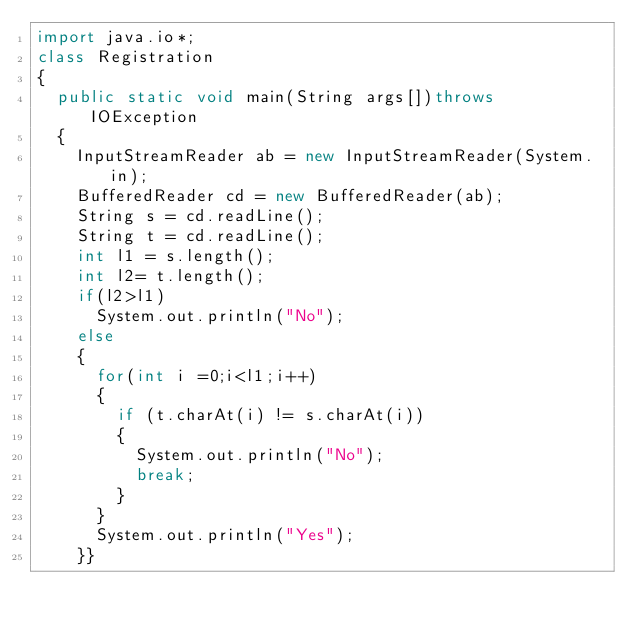Convert code to text. <code><loc_0><loc_0><loc_500><loc_500><_Java_>import java.io*;
class Registration
{
  public static void main(String args[])throws IOException
  {
    InputStreamReader ab = new InputStreamReader(System.in);
    BufferedReader cd = new BufferedReader(ab);
    String s = cd.readLine();
    String t = cd.readLine();
    int l1 = s.length();
    int l2= t.length();
    if(l2>l1)
      System.out.println("No");
    else
    {
      for(int i =0;i<l1;i++)
      {
        if (t.charAt(i) != s.charAt(i))
        {
          System.out.println("No");
          break;
        }
      }
      System.out.println("Yes");
    }}</code> 